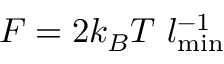<formula> <loc_0><loc_0><loc_500><loc_500>F = 2 k _ { B } T l _ { \min } ^ { - 1 }</formula> 